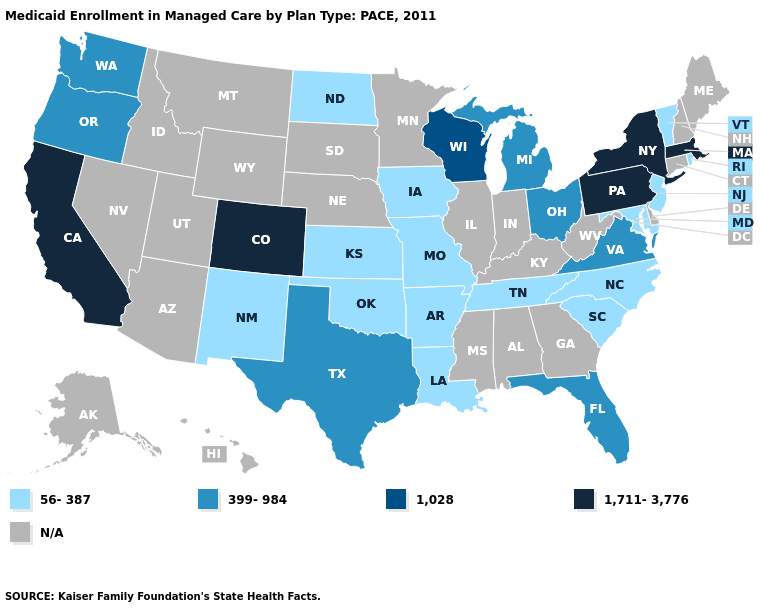Does Massachusetts have the highest value in the USA?
Short answer required. Yes. What is the highest value in the USA?
Keep it brief. 1,711-3,776. What is the value of Idaho?
Answer briefly. N/A. Name the states that have a value in the range 56-387?
Quick response, please. Arkansas, Iowa, Kansas, Louisiana, Maryland, Missouri, New Jersey, New Mexico, North Carolina, North Dakota, Oklahoma, Rhode Island, South Carolina, Tennessee, Vermont. Name the states that have a value in the range 56-387?
Concise answer only. Arkansas, Iowa, Kansas, Louisiana, Maryland, Missouri, New Jersey, New Mexico, North Carolina, North Dakota, Oklahoma, Rhode Island, South Carolina, Tennessee, Vermont. Which states hav the highest value in the MidWest?
Answer briefly. Wisconsin. What is the value of Ohio?
Be succinct. 399-984. What is the lowest value in the USA?
Concise answer only. 56-387. What is the value of South Carolina?
Write a very short answer. 56-387. What is the value of Arkansas?
Be succinct. 56-387. Does the map have missing data?
Keep it brief. Yes. Name the states that have a value in the range 56-387?
Write a very short answer. Arkansas, Iowa, Kansas, Louisiana, Maryland, Missouri, New Jersey, New Mexico, North Carolina, North Dakota, Oklahoma, Rhode Island, South Carolina, Tennessee, Vermont. Is the legend a continuous bar?
Answer briefly. No. Name the states that have a value in the range N/A?
Be succinct. Alabama, Alaska, Arizona, Connecticut, Delaware, Georgia, Hawaii, Idaho, Illinois, Indiana, Kentucky, Maine, Minnesota, Mississippi, Montana, Nebraska, Nevada, New Hampshire, South Dakota, Utah, West Virginia, Wyoming. 